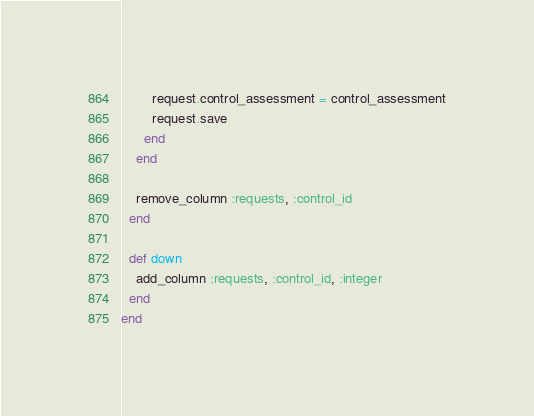Convert code to text. <code><loc_0><loc_0><loc_500><loc_500><_Ruby_>
        request.control_assessment = control_assessment
        request.save
      end
    end

    remove_column :requests, :control_id
  end

  def down
    add_column :requests, :control_id, :integer
  end
end
</code> 